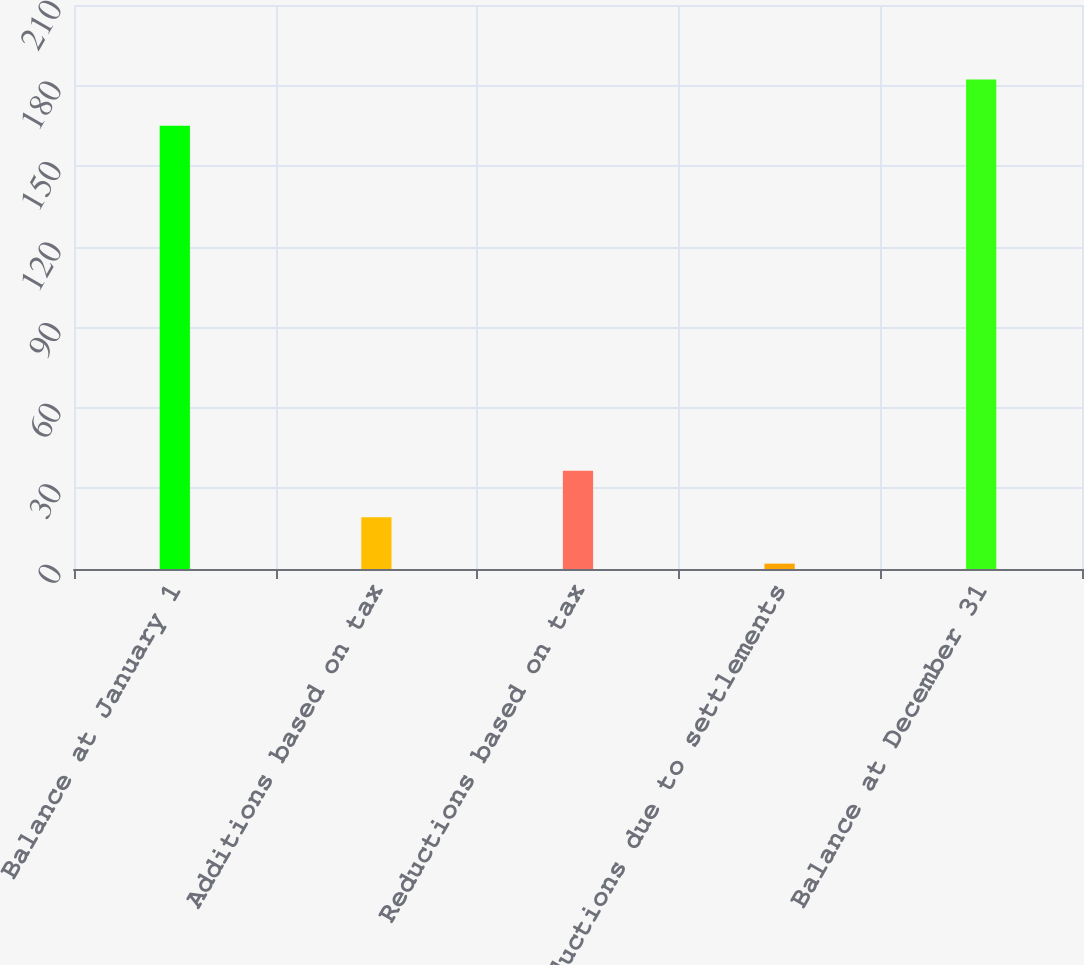<chart> <loc_0><loc_0><loc_500><loc_500><bar_chart><fcel>Balance at January 1<fcel>Additions based on tax<fcel>Reductions based on tax<fcel>Reductions due to settlements<fcel>Balance at December 31<nl><fcel>165<fcel>19.3<fcel>36.6<fcel>2<fcel>182.3<nl></chart> 